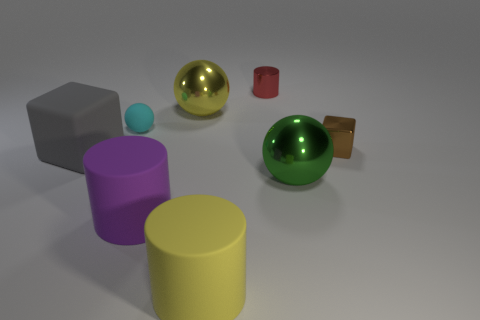Add 1 tiny brown shiny blocks. How many objects exist? 9 Subtract all blocks. How many objects are left? 6 Subtract all metal cylinders. Subtract all purple things. How many objects are left? 6 Add 2 red things. How many red things are left? 3 Add 1 red things. How many red things exist? 2 Subtract 1 brown blocks. How many objects are left? 7 